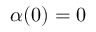Convert formula to latex. <formula><loc_0><loc_0><loc_500><loc_500>\alpha ( 0 ) = 0</formula> 